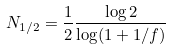<formula> <loc_0><loc_0><loc_500><loc_500>N _ { 1 / 2 } = \frac { 1 } { 2 } \frac { \log { 2 } } { \log ( 1 + 1 / f ) }</formula> 